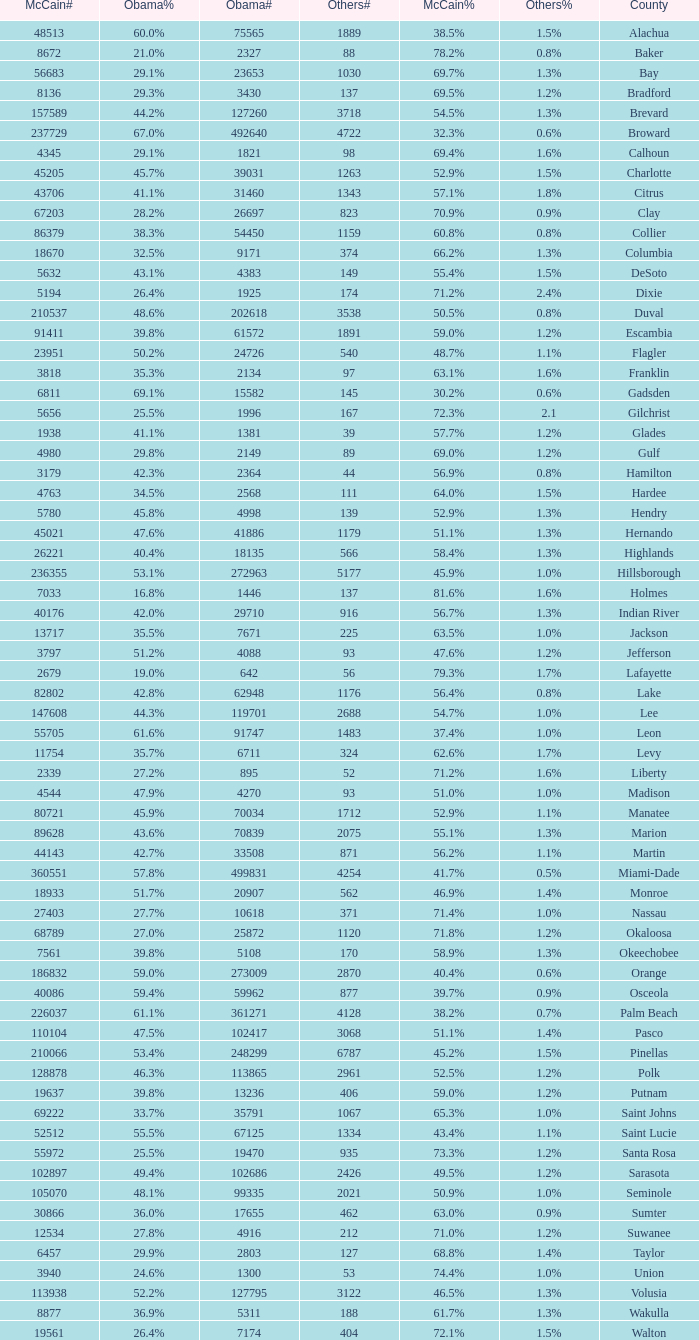What percentage was the others vote when McCain had 52.9% and less than 45205.0 voters? 1.3%. 